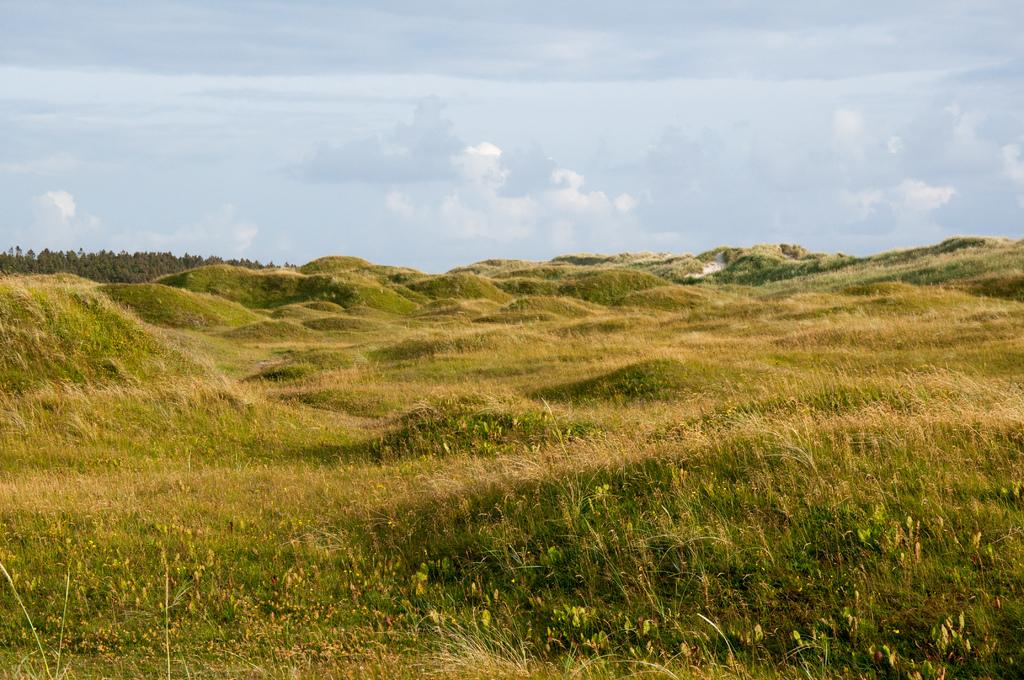What type of vegetation can be seen in the image? There is grass, plants, and trees in the image. What part of the natural environment is visible in the image? The sky is visible in the image. Where are the children playing with the fruit in the image? There are no children or fruit present in the image. What type of map is visible in the image? There is no map present in the image. 